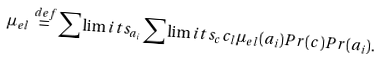Convert formula to latex. <formula><loc_0><loc_0><loc_500><loc_500>\mu _ { e l } \stackrel { d e f } { = } \sum \lim i t s _ { a _ { i } } \sum \lim i t s _ { c } c _ { l } \mu _ { e l } ( a _ { i } ) P r ( c ) P r ( a _ { i } ) .</formula> 